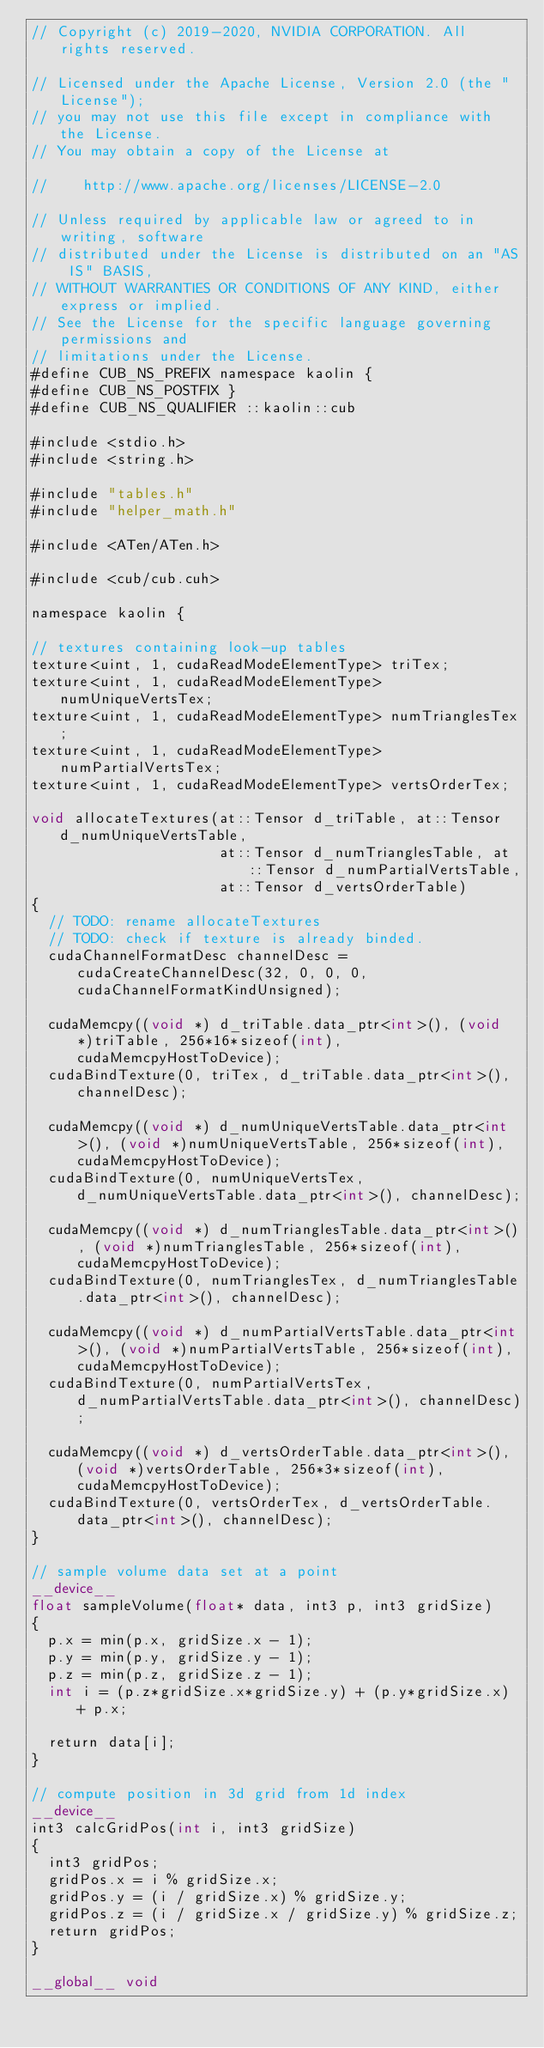Convert code to text. <code><loc_0><loc_0><loc_500><loc_500><_Cuda_>// Copyright (c) 2019-2020, NVIDIA CORPORATION. All rights reserved.

// Licensed under the Apache License, Version 2.0 (the "License");
// you may not use this file except in compliance with the License.
// You may obtain a copy of the License at

//    http://www.apache.org/licenses/LICENSE-2.0

// Unless required by applicable law or agreed to in writing, software
// distributed under the License is distributed on an "AS IS" BASIS,
// WITHOUT WARRANTIES OR CONDITIONS OF ANY KIND, either express or implied.
// See the License for the specific language governing permissions and
// limitations under the License.
#define CUB_NS_PREFIX namespace kaolin {
#define CUB_NS_POSTFIX }
#define CUB_NS_QUALIFIER ::kaolin::cub

#include <stdio.h>
#include <string.h>

#include "tables.h"
#include "helper_math.h"

#include <ATen/ATen.h>

#include <cub/cub.cuh>

namespace kaolin {

// textures containing look-up tables
texture<uint, 1, cudaReadModeElementType> triTex;
texture<uint, 1, cudaReadModeElementType> numUniqueVertsTex;
texture<uint, 1, cudaReadModeElementType> numTrianglesTex;
texture<uint, 1, cudaReadModeElementType> numPartialVertsTex;
texture<uint, 1, cudaReadModeElementType> vertsOrderTex;

void allocateTextures(at::Tensor d_triTable, at::Tensor d_numUniqueVertsTable, 
                      at::Tensor d_numTrianglesTable, at::Tensor d_numPartialVertsTable,
                      at::Tensor d_vertsOrderTable)
{
  // TODO: rename allocateTextures
  // TODO: check if texture is already binded.
  cudaChannelFormatDesc channelDesc = cudaCreateChannelDesc(32, 0, 0, 0, cudaChannelFormatKindUnsigned);

  cudaMemcpy((void *) d_triTable.data_ptr<int>(), (void *)triTable, 256*16*sizeof(int), cudaMemcpyHostToDevice);
  cudaBindTexture(0, triTex, d_triTable.data_ptr<int>(), channelDesc);

  cudaMemcpy((void *) d_numUniqueVertsTable.data_ptr<int>(), (void *)numUniqueVertsTable, 256*sizeof(int), cudaMemcpyHostToDevice);
  cudaBindTexture(0, numUniqueVertsTex, d_numUniqueVertsTable.data_ptr<int>(), channelDesc);

  cudaMemcpy((void *) d_numTrianglesTable.data_ptr<int>(), (void *)numTrianglesTable, 256*sizeof(int), cudaMemcpyHostToDevice);
  cudaBindTexture(0, numTrianglesTex, d_numTrianglesTable.data_ptr<int>(), channelDesc);

  cudaMemcpy((void *) d_numPartialVertsTable.data_ptr<int>(), (void *)numPartialVertsTable, 256*sizeof(int), cudaMemcpyHostToDevice);
  cudaBindTexture(0, numPartialVertsTex, d_numPartialVertsTable.data_ptr<int>(), channelDesc);

  cudaMemcpy((void *) d_vertsOrderTable.data_ptr<int>(), (void *)vertsOrderTable, 256*3*sizeof(int), cudaMemcpyHostToDevice);
  cudaBindTexture(0, vertsOrderTex, d_vertsOrderTable.data_ptr<int>(), channelDesc);
}

// sample volume data set at a point
__device__
float sampleVolume(float* data, int3 p, int3 gridSize)
{
  p.x = min(p.x, gridSize.x - 1);
  p.y = min(p.y, gridSize.y - 1);
  p.z = min(p.z, gridSize.z - 1);
  int i = (p.z*gridSize.x*gridSize.y) + (p.y*gridSize.x) + p.x;

  return data[i];
}

// compute position in 3d grid from 1d index
__device__
int3 calcGridPos(int i, int3 gridSize)
{
  int3 gridPos;
  gridPos.x = i % gridSize.x;
  gridPos.y = (i / gridSize.x) % gridSize.y;
  gridPos.z = (i / gridSize.x / gridSize.y) % gridSize.z;
  return gridPos;
}

__global__ void</code> 